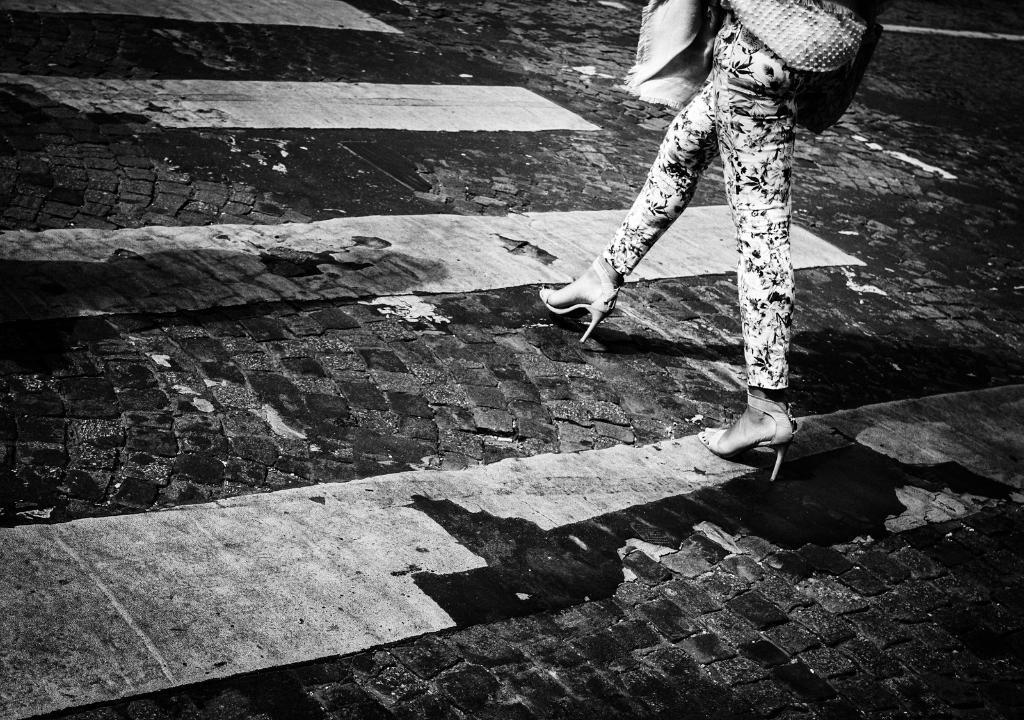Can you describe this image briefly? In this image, we can see a person is walking on the road. Here we can see few lines. 